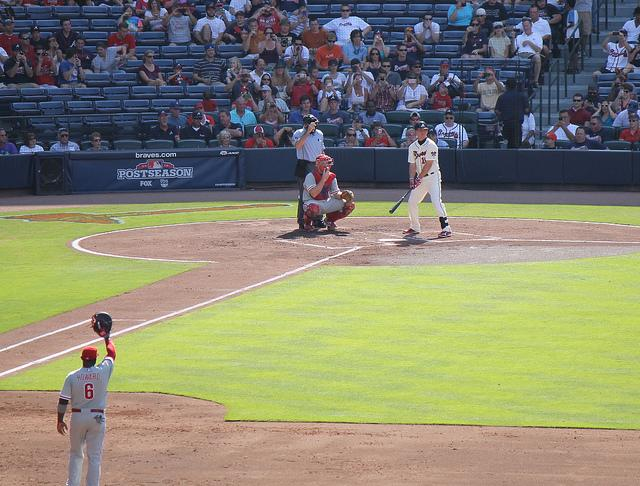What switch hitting Atlanta Braves legend is at the plate? chipper jones 